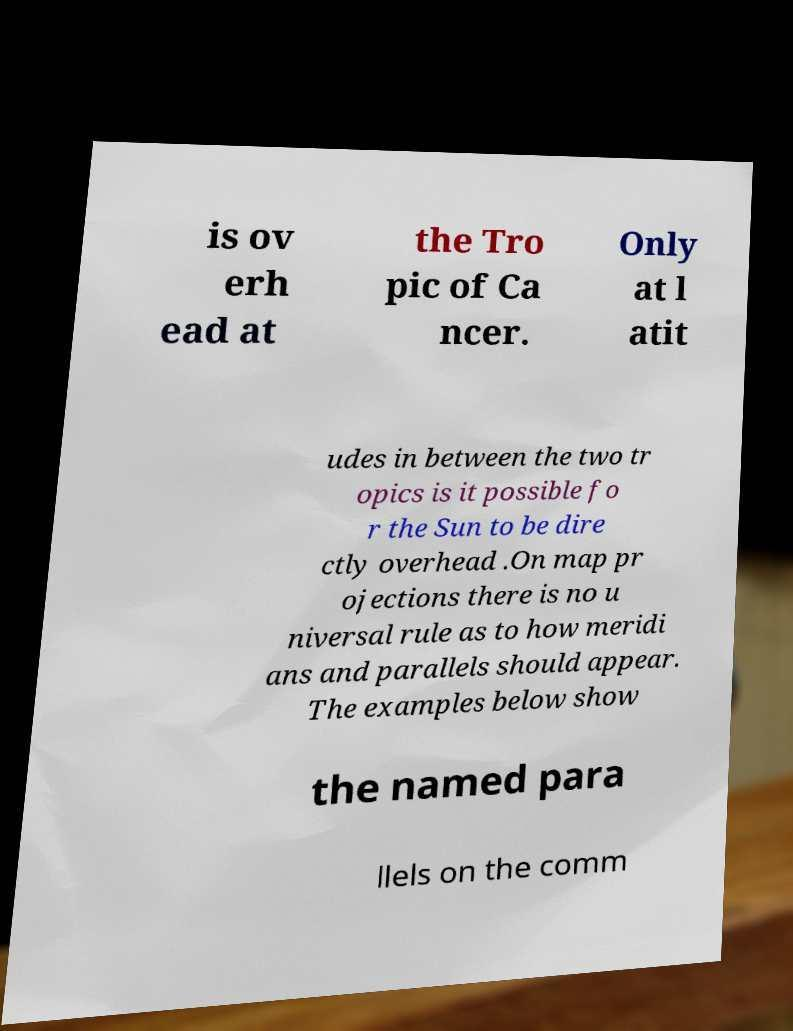Can you accurately transcribe the text from the provided image for me? is ov erh ead at the Tro pic of Ca ncer. Only at l atit udes in between the two tr opics is it possible fo r the Sun to be dire ctly overhead .On map pr ojections there is no u niversal rule as to how meridi ans and parallels should appear. The examples below show the named para llels on the comm 